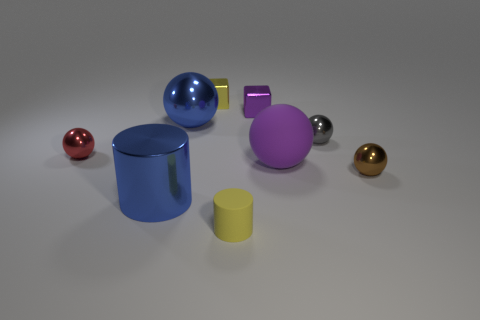Subtract all tiny gray spheres. How many spheres are left? 4 Subtract all cubes. How many objects are left? 7 Subtract 1 blocks. How many blocks are left? 1 Subtract all brown spheres. How many spheres are left? 4 Add 1 purple blocks. How many purple blocks are left? 2 Add 9 gray metallic balls. How many gray metallic balls exist? 10 Subtract 0 green balls. How many objects are left? 9 Subtract all gray cylinders. Subtract all gray blocks. How many cylinders are left? 2 Subtract all cyan balls. How many purple cubes are left? 1 Subtract all small brown rubber cylinders. Subtract all blue cylinders. How many objects are left? 8 